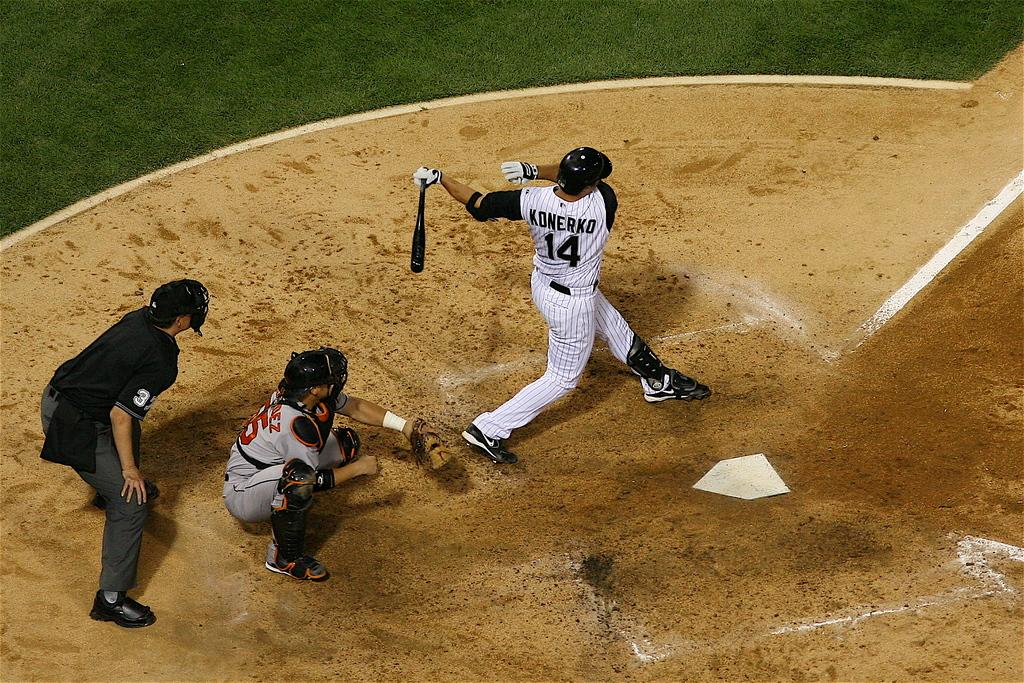How many people are involved in the activity shown in the image? There are two players in the image. What is the condition of the person on the ground in the image? The person on the ground is not described in the image, so we cannot determine their condition. What equipment is being used by one of the players? One of the players is holding a baseball bat. What type of surface is visible in the image? Grass is visible in the image. What team does the beginner player belong to in the image? There is no information about the players' skill levels or team affiliations in the image, so we cannot determine which team the beginner player belongs to. 